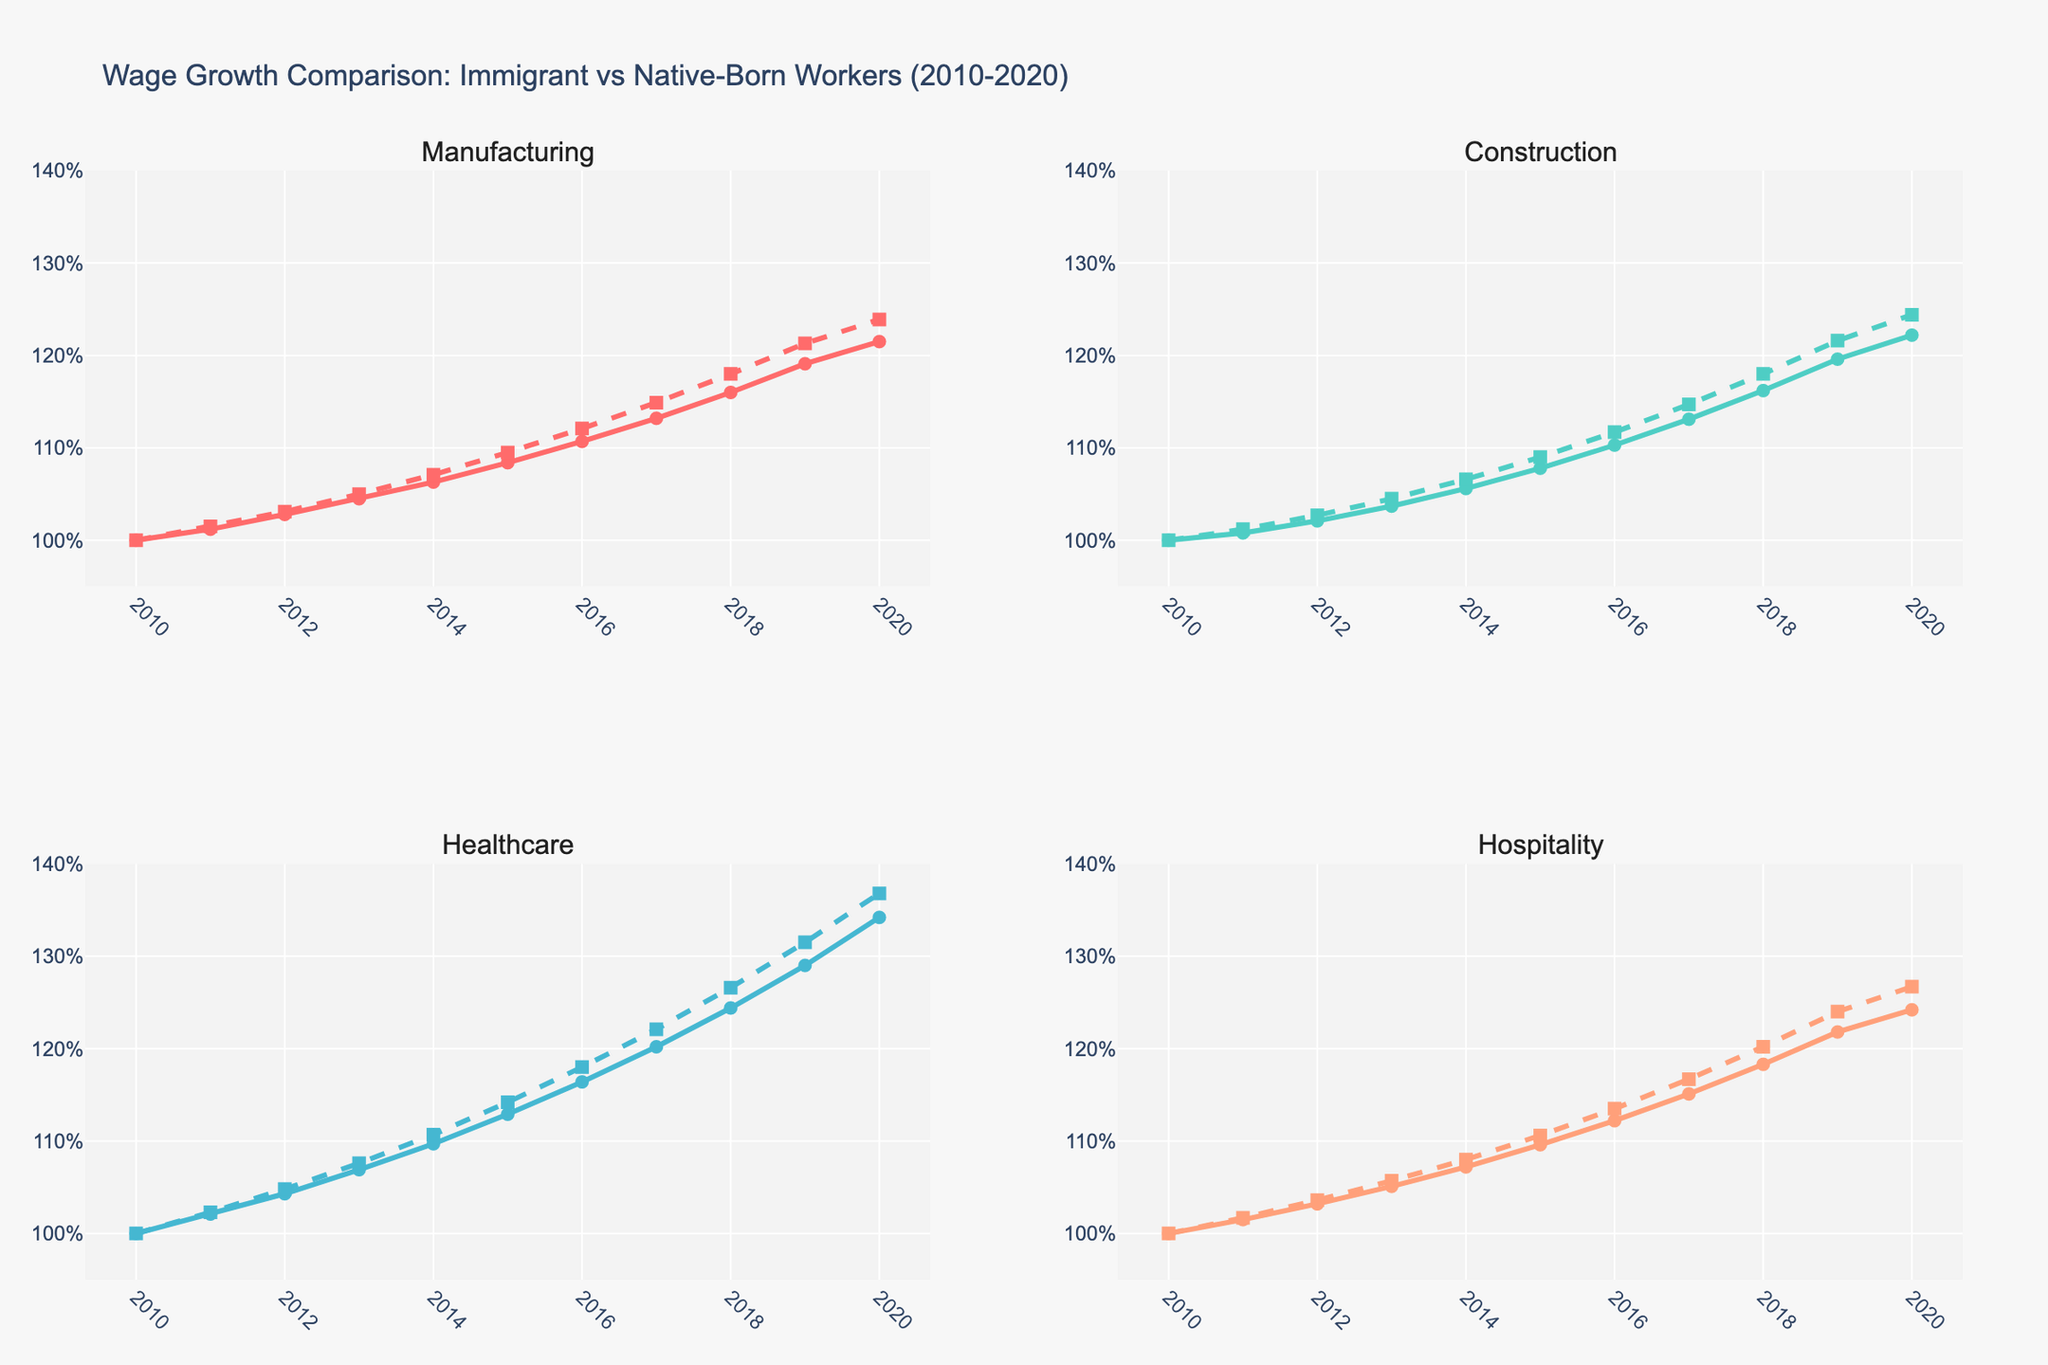What is the annual wage growth rate for immigrant workers in the Healthcare sector from 2010 to 2020? To find the annual wage growth rate, we take the wage in 2020 (134.2%) and divide it by the wage in 2010 (100%), then raise it to the power of (1/10) to get the compound annual growth rate (CAGR). Calculation: (134.2 / 100)^(1/10) = 1.029, thus the rate is approximately 2.9% per year.
Answer: 2.9% In which sector did native-born workers experience the highest wage growth from 2010 to 2020? By comparing the ending values in 2020 for all sectors for native-born workers: Manufacturing (123.9%), Construction (124.4%), Healthcare (136.8%), and Hospitality (126.7%). Healthcare has the highest value.
Answer: Healthcare How does the wage growth of immigrant workers in the Construction sector in 2020 compare to native-born workers in the same sector? Comparing the values for 2020 in the Construction sector: Immigrant (122.2%) vs. Native (124.4%). Immigrant workers have lower wage growth.
Answer: Lower What is the average wage growth for native-born workers across all sectors in 2020? To find the average, sum the 2020 values for native-born workers in all sectors and divide by the number of sectors: (123.9% + 124.4% + 136.8% + 126.7%) / 4 = 127.95%.
Answer: 127.95% Which sector shows the smallest difference in wage growth between immigrant and native-born workers in 2020? By calculating the absolute differences in 2020: Manufacturing (123.9%-121.5%=2.4), Construction (124.4%-122.2%=2.2), Healthcare (136.8%-134.2%=2.6), and Hospitality (126.7%-124.2%=2.5). Construction has the smallest difference.
Answer: Construction Did the wages for immigrant workers in the Hospitality sector increase consistently each year from 2010 to 2020? By observing the line trend from 2010 to 2020, the values increase every year without decline: 100, 101.5, 103.2, 105.1, 107.2, 109.6, 112.2, 115.1, 118.3, 121.8, 124.2.
Answer: Yes In the Manufacturing sector, which year shows the highest growth rate for native-born workers? By finding the highest annual increase for native-born workers in Manufacturing: the year with the highest yearly difference is 2018-2019 (121.3 - 118.0 = 3.3%).
Answer: 2019 How has the wage growth for immigrant workers in the Healthcare sector in 2020 compared to 2015? Compare the values for 2020 and 2015 in Healthcare for immigrants: 134.2% in 2020 vs. 112.9% in 2015. So, 134.2 - 112.9 = 21.3%.
Answer: 21.3% What is the total wage growth for native-born workers in the Hospitality sector from 2013 to 2018? Difference between 2018 and 2013 values for native-born Hospitality: 120.2% - 105.7% = 14.5%.
Answer: 14.5% 